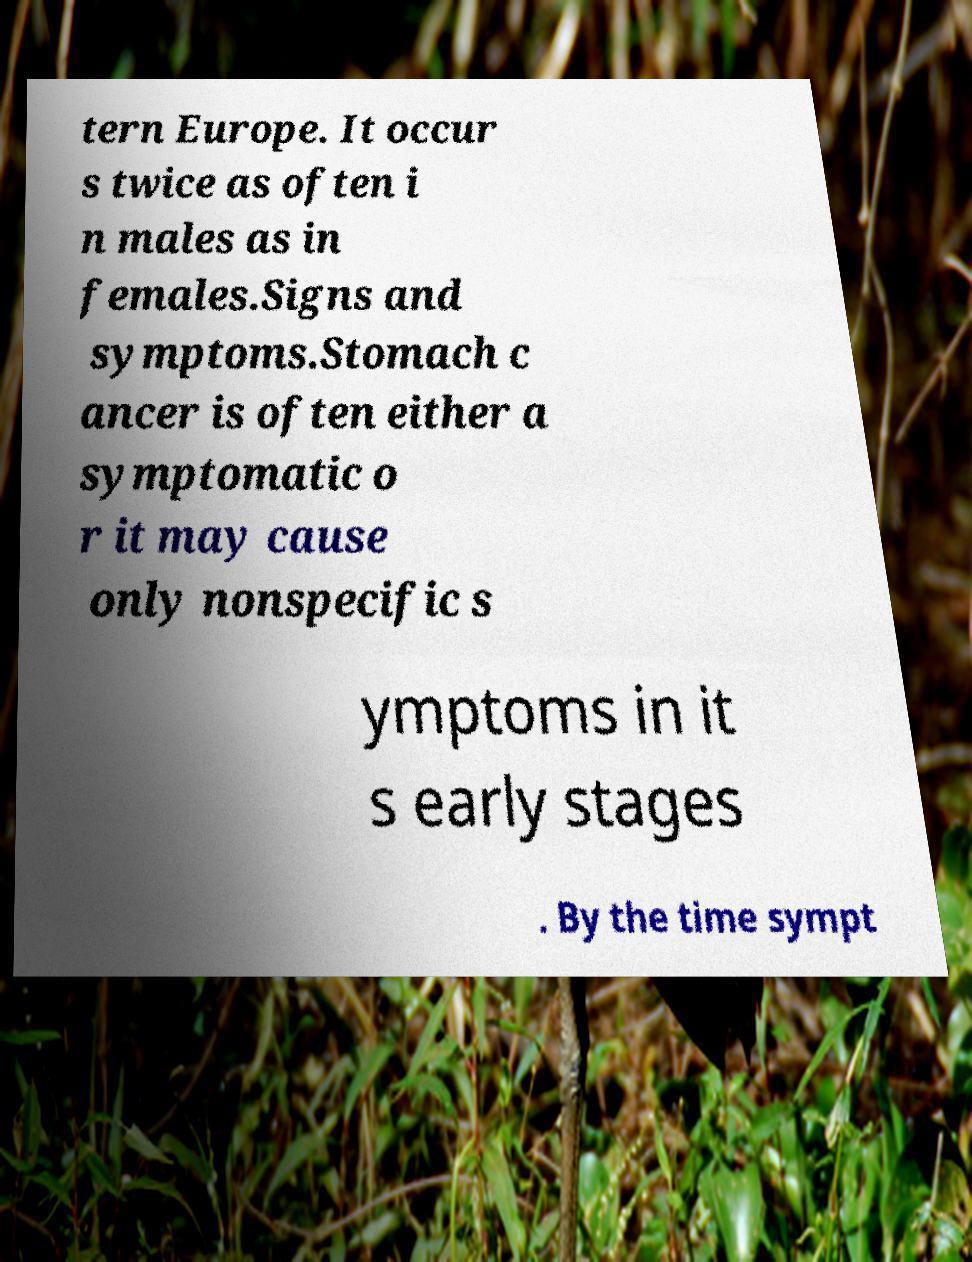What messages or text are displayed in this image? I need them in a readable, typed format. tern Europe. It occur s twice as often i n males as in females.Signs and symptoms.Stomach c ancer is often either a symptomatic o r it may cause only nonspecific s ymptoms in it s early stages . By the time sympt 